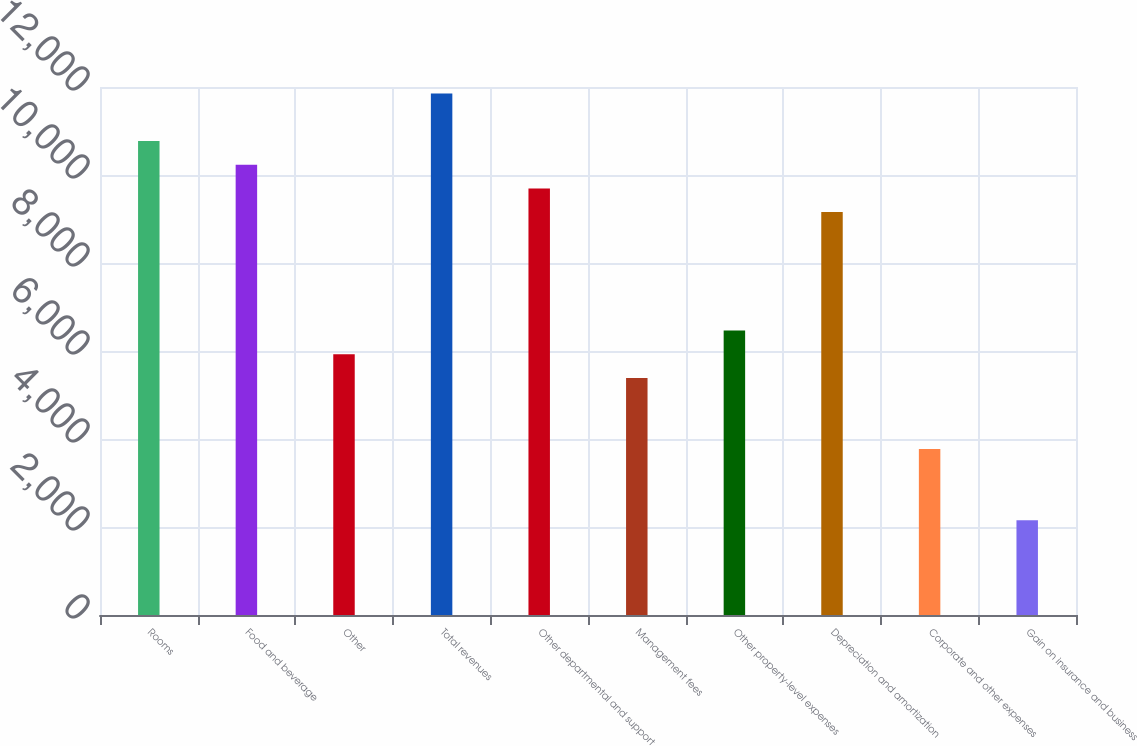<chart> <loc_0><loc_0><loc_500><loc_500><bar_chart><fcel>Rooms<fcel>Food and beverage<fcel>Other<fcel>Total revenues<fcel>Other departmental and support<fcel>Management fees<fcel>Other property-level expenses<fcel>Depreciation and amortization<fcel>Corporate and other expenses<fcel>Gain on insurance and business<nl><fcel>10773.2<fcel>10234.5<fcel>5925.58<fcel>11850.4<fcel>9695.92<fcel>5386.96<fcel>6464.2<fcel>9157.3<fcel>3771.1<fcel>2155.24<nl></chart> 